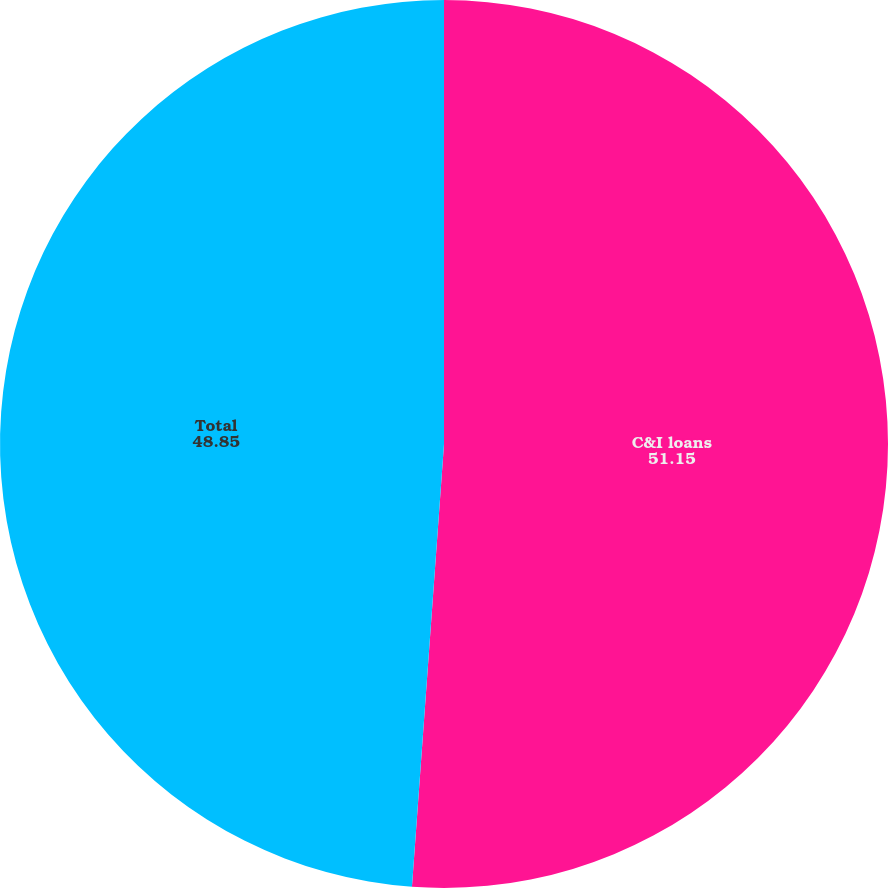Convert chart. <chart><loc_0><loc_0><loc_500><loc_500><pie_chart><fcel>C&I loans<fcel>Total<nl><fcel>51.15%<fcel>48.85%<nl></chart> 